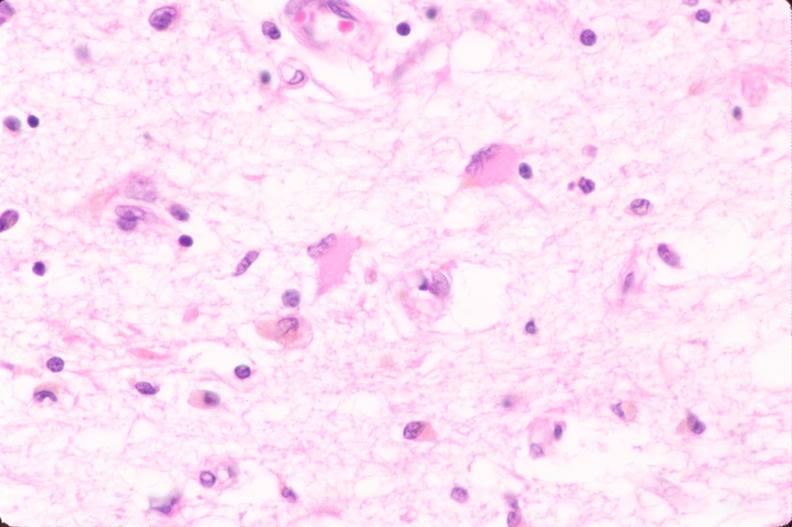why does this image show brain, infarct?
Answer the question using a single word or phrase. Due to ruptured saccular aneurysm and thrombosis of right middle cerebral artery plasmacytic astrocytes 